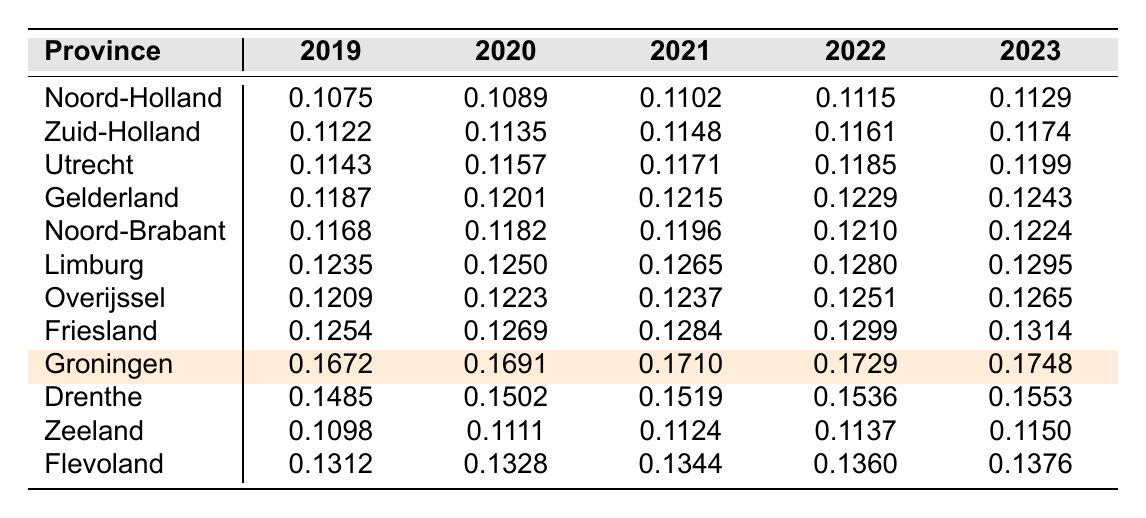What is the property tax rate for Noord-Holland in 2023? By finding the row for Noord-Holland and looking at the column for the year 2023, the value is 0.1129.
Answer: 0.1129 Which province has the highest property tax rate in 2021? Looking at the 2021 column for all provinces, Groningen has the highest tax rate of 0.1710.
Answer: Groningen What was the average property tax rate for Limburg from 2019 to 2023? Summing the tax rates for Limburg from 2019 (0.1235), 2020 (0.1250), 2021 (0.1265), 2022 (0.1280), and 2023 (0.1295) gives 0.6325. Dividing by 5 gives an average of 0.1265.
Answer: 0.1265 Is the property tax rate in Zeeland consistently below 0.115 from 2019 to 2023? The tax rates for Zeeland are 0.1098 (2019), 0.1111 (2020), 0.1124 (2021), 0.1137 (2022), and 0.1150 (2023), which shows that it is below 0.115 in all years except the last. Hence, it is not consistent.
Answer: No What is the difference in property tax rates between Groningen in 2023 and Zeeland in 2023? The tax rate for Groningen in 2023 is 0.1748 and for Zeeland it is 0.1150. Subtracting gives 0.1748 - 0.1150 = 0.0598.
Answer: 0.0598 Which province has seen the largest increase in tax rate from 2019 to 2023? Examining the tax rates from 2019 to 2023: Groningen increased from 0.1672 to 0.1748 (0.0076), and Limburg increased from 0.1235 to 0.1295 (0.0060). Therefore, the largest increase is for Groningen.
Answer: Groningen Was the average property tax rate for the provinces in 2020 higher than 0.120? Calculating the average of the 2020 rates (0.1089 + 0.1135 + 0.1157 + 0.1201 + 0.1182 + 0.1250 + 0.1223 + 0.1269 + 0.1691 + 0.1502 + 0.1111 + 0.1328) gives approximately 0.1243, which is greater than 0.120.
Answer: Yes What is the trend in tax rates for Gelderland from 2019 to 2023? The tax rates for Gelderland show a steady increase from 0.1187 in 2019 to 0.1243 in 2023, indicating a consistent upward trend.
Answer: Increasing Which province had the lowest property tax rate in 2022? Checking the 2022 column reveals that Zeeland had the lowest tax rate at 0.1137.
Answer: Zeeland How much did the property tax rate in Overijssel increase from 2019 to 2023? The tax rate for Overijssel increased from 0.1209 in 2019 to 0.1265 in 2023. The increase is 0.1265 - 0.1209 = 0.0056.
Answer: 0.0056 